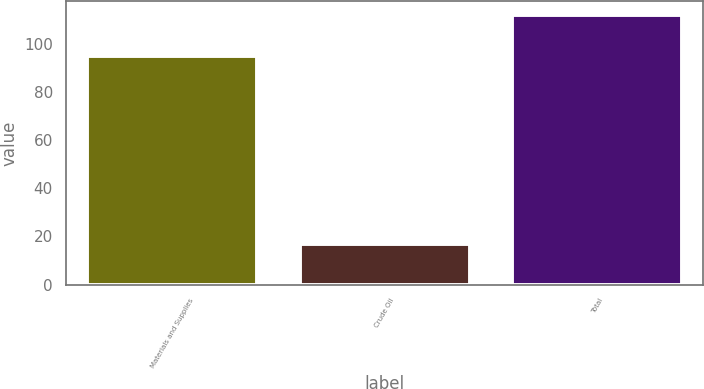Convert chart. <chart><loc_0><loc_0><loc_500><loc_500><bar_chart><fcel>Materials and Supplies<fcel>Crude Oil<fcel>Total<nl><fcel>95<fcel>17<fcel>112<nl></chart> 